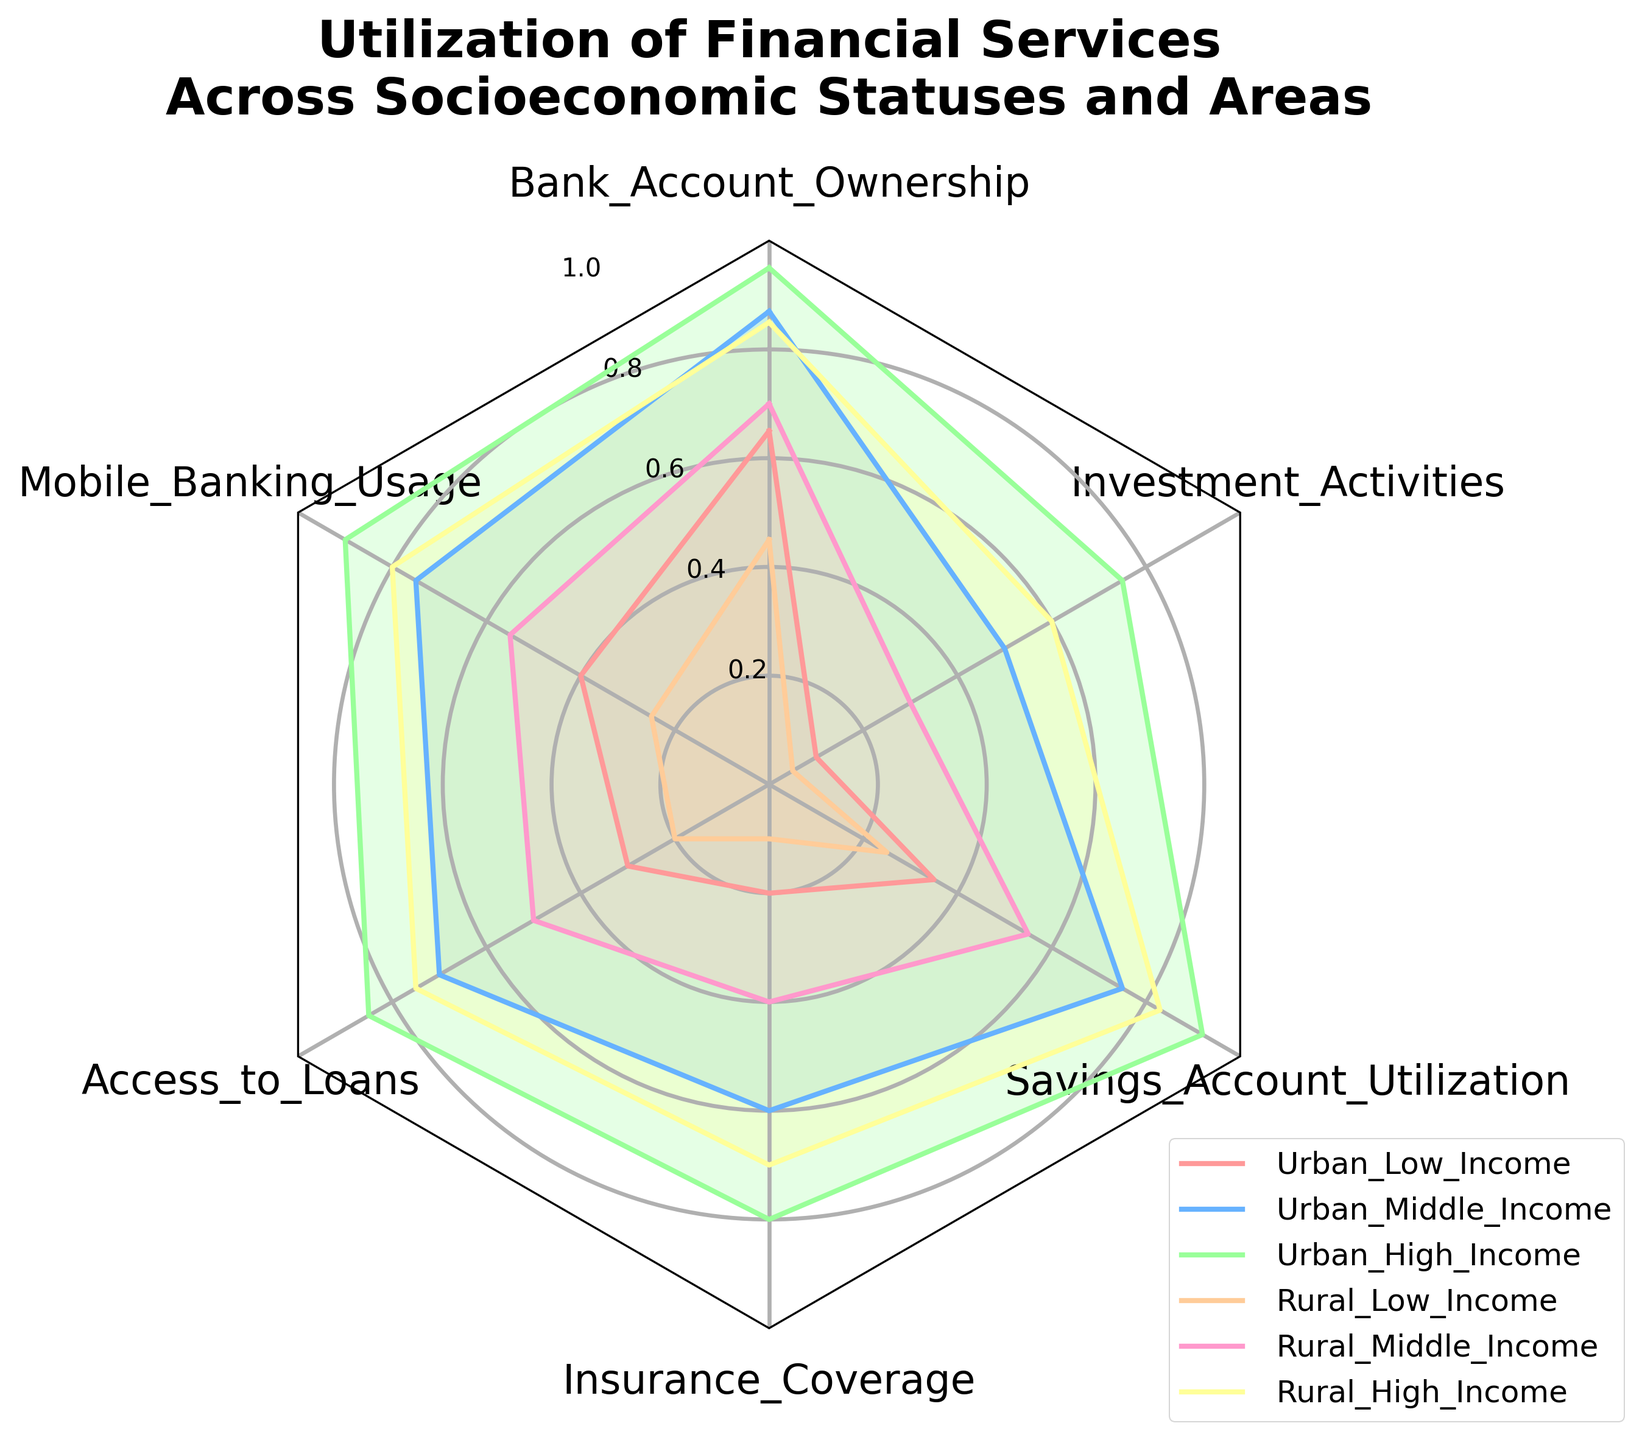What title is displayed at the top of the radar chart? The title at the top of the radar chart is in bold and large fonts, indicating the focus of the visual.
Answer: Utilization of Financial Services Across Socioeconomic Statuses and Areas Which urban income group has the highest utilization of insurance coverage? The radar chart displays different service utilizations for urban and rural areas. Looking at the sector representing 'Insurance Coverage' among urban groups, the highest mark is achieved by the Urban High Income group.
Answer: Urban High Income What is the difference in bank account ownership between Rural Low Income and Rural High Income groups? The 'Bank Account Ownership' axis shows the values for both Rural Low Income and Rural High Income groups. The value for Rural Low Income is 0.45 and for Rural High Income is 0.85. The difference is calculated as 0.85 - 0.45.
Answer: 0.40 For which financial service category is there the smallest difference between Urban Low Income and Rural Low Income groups? To find the smallest difference, we compare the values for Urban Low Income and Rural Low Income across all categories. The smallest difference is in 'Investment Activities', where Urban Low Income is at 0.10 and Rural Low Income is at 0.05. The difference is 0.05.
Answer: Investment Activities In which financial service category do Rural Middle Income groups have higher utilization compared to Urban Low Income groups? Comparing values for each category, we look for where Rural Middle Income values exceed Urban Low Income values. In 'Mobile Banking Usage' and 'Savings Account Utilization', Rural Middle Income (0.55 for both) is higher than Urban Low Income (0.40 and 0.35 respectively).
Answer: Mobile Banking Usage, Savings Account Utilization How many axes are represented on the radar chart? The number of axes corresponds to the number of financial service categories displayed radially on the radar chart.
Answer: 6 Which socioeconomic status group utilizes mobile banking the least in rural areas? Observing the 'Mobile Banking Usage' axis for rural groups, the lowest value appears at Rural Low Income with a value of 0.25.
Answer: Rural Low Income Which category shows the greatest utilization difference between Urban High Income and Rural Low Income groups? We compare the difference in values across each category for Urban High Income and Rural Low Income groups. The largest difference is seen in 'Mobile Banking Usage' between 0.90 (Urban High Income) and 0.25 (Rural Low Income), giving a difference of 0.65.
Answer: Mobile Banking Usage What is the average utilization of Investment Activities across all groups in urban areas? Summing the values for Investment Activities in Urban areas: 0.10 (Low Income) + 0.50 (Middle Income) + 0.75 (High Income) = 1.35. Dividing by 3 gives the average value of 1.35 / 3.
Answer: 0.45 